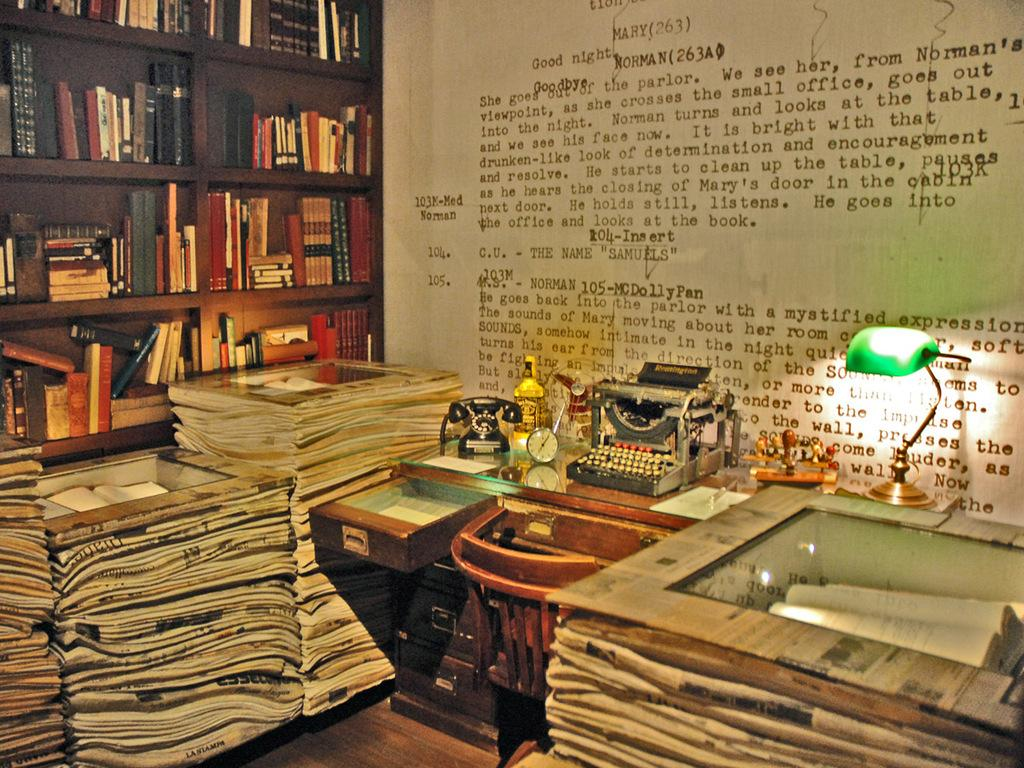<image>
Render a clear and concise summary of the photo. Stacks of newspapers in front of an old typewriter and a large pic that says Mary 263 